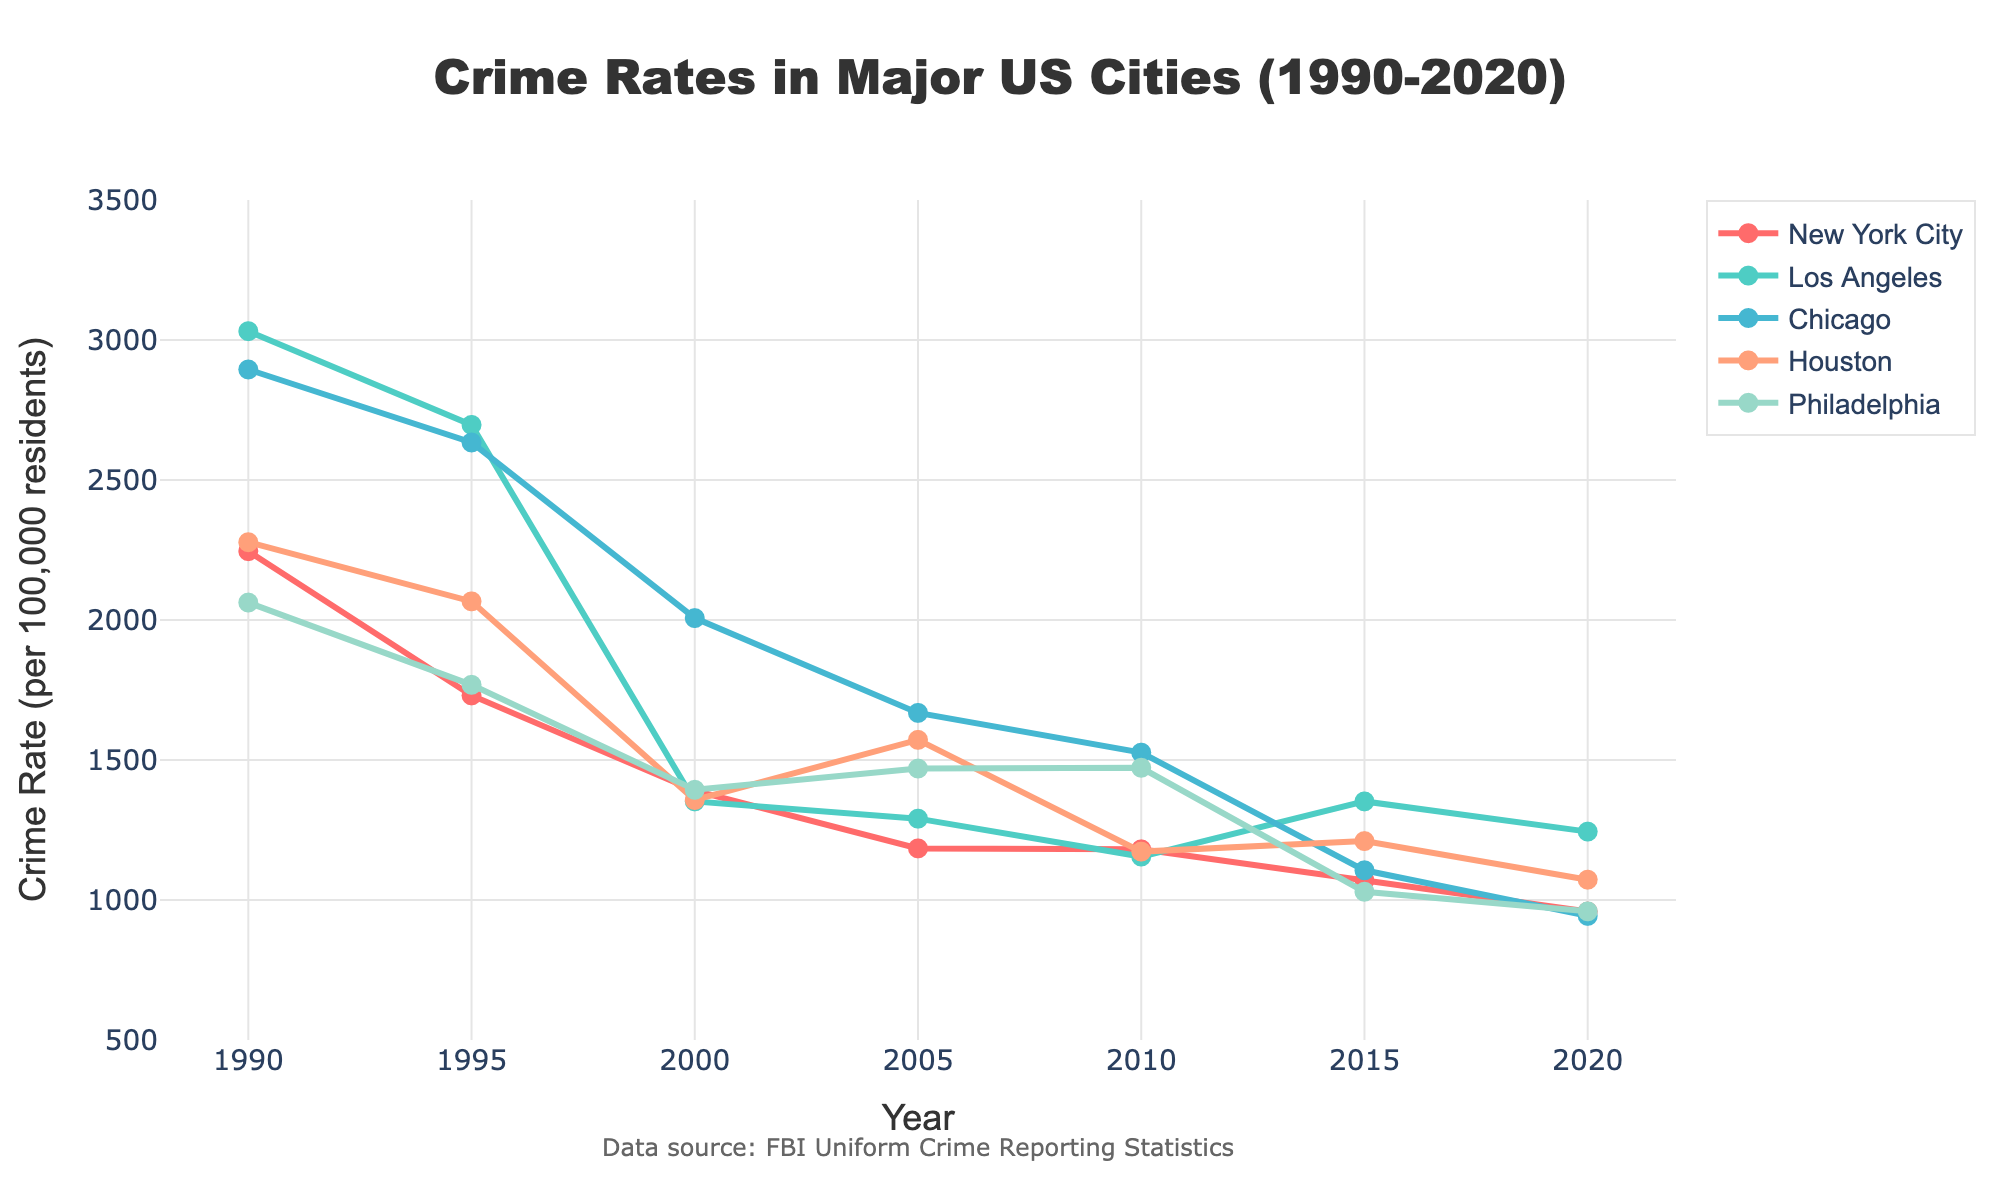Which city had the highest crime rate in 1990? By looking at the figure for the year 1990 and comparing the crime rates for each city, we see that Los Angeles had the highest crime rate.
Answer: Los Angeles Which city showed the greatest overall decrease in crime rates from 1990 to 2020? By comparing the crime rates of all the cities in 1990 and 2020, we can calculate the difference for each city. New York City had the greatest decrease, dropping from 2245.8 to 958.7, which is a decrease of 1287.1.
Answer: New York City In which year did Philadelphia have a crime rate closest to 1400? By looking at Philadelphia's crime rates in each year and finding the one closest to 1400, we see that it was in the year 2000 with a rate of 1393.6.
Answer: 2000 Between 2000 and 2010, which city had a smaller change in crime rate: New York City or Chicago? By calculating the change in crime rates for both cities between 2000 and 2010, New York City's rate changed from 1390.2 to 1180.9 (a change of 209.3), and Chicago's rate changed from 2006.8 to 1526.3 (a change of 480.5). Therefore, New York City had a smaller change.
Answer: New York City Which city had the most consistent decline in crime rate over the 30 years? By examining the trend of each city's crime rates from 1990 to 2020, we can determine consistency by observing the smoothness and steadiness of the decline. New York City shows a consistently declining trend with no major spikes or plateaus.
Answer: New York City What was the average crime rate in Houston over the years? To find the average crime rate in Houston, sum the crime rates for each year listed (2277.8 + 2066.5 + 1357.1 + 1571.9 + 1172.8 + 1210.4 + 1072.6) and then divide by the number of years (7). (Sum = 10729.1, Average = 10729.1 / 7)
Answer: 1532.7 How did Los Angeles' crime rate in 2020 compare to its crime rate in 1995? By examining the figure for Los Angeles' crime rates in 2020 and 1995, we find that the crime rate dropped from 2696.7 in 1995 to 1244.3 in 2020. Thus, the 2020 rate is lower.
Answer: Lower Which two cities had crime rates closer to each other in 2015? By comparing the rates of all cities in 2015, we see that New York City and Philadelphia had crime rates of 1069.5 and 1029.5 respectively, closest to each other.
Answer: New York City and Philadelphia 